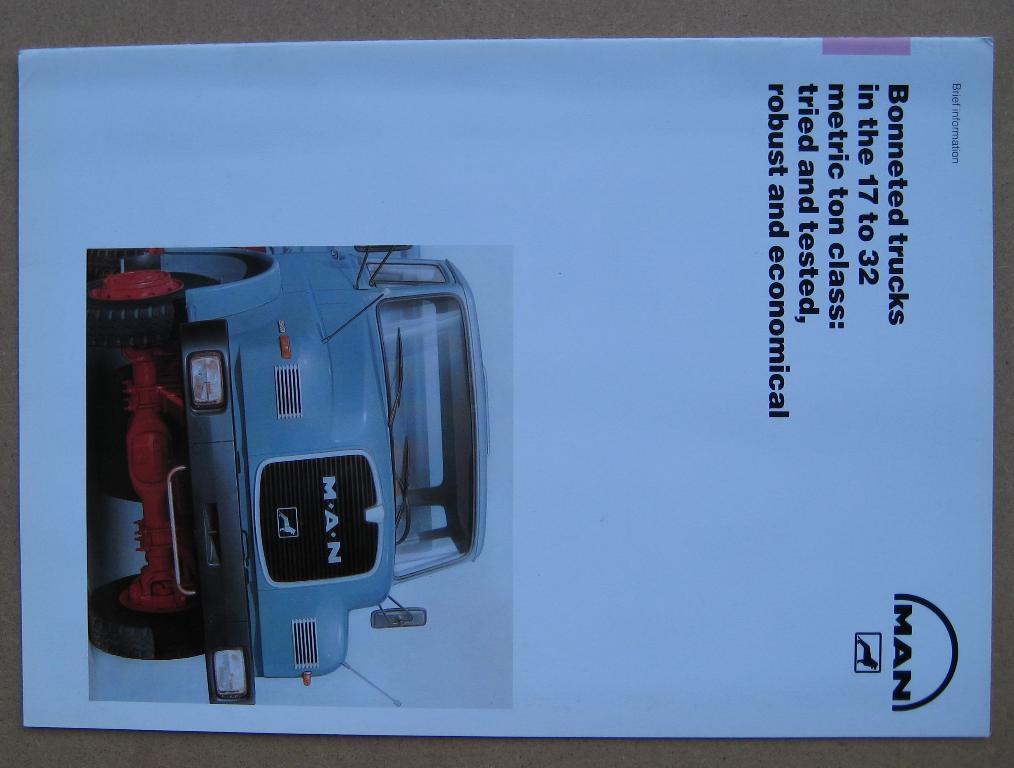In one or two sentences, can you explain what this image depicts? In this image we can see there is a poser. On the poster there is some text and an image of a vehicle. 